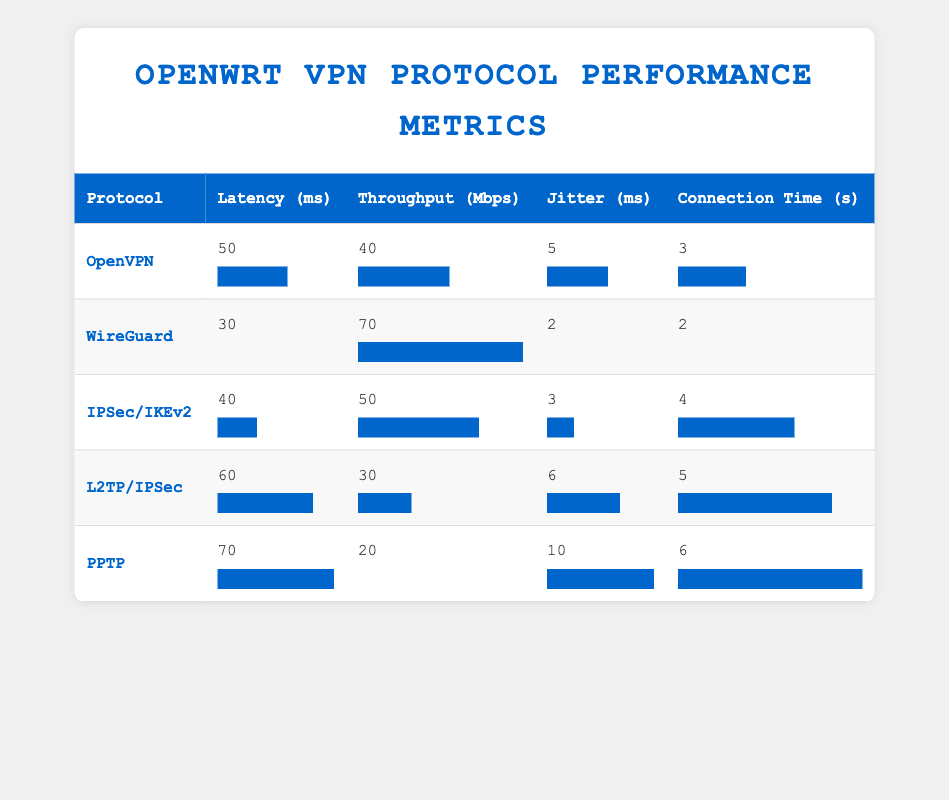What is the latency of OpenVPN? The latency of OpenVPN can be found in the table under the "Latency (ms)" column for the OpenVPN row, which shows 50 milliseconds.
Answer: 50 ms Which VPN protocol has the highest throughput? By reviewing the "Throughput (Mbps)" column, WireGuard is the protocol with the highest throughput at 70 Mbps.
Answer: WireGuard Is there a VPN protocol with a connection time less than 3 seconds? Looking at the "Connection Time (s)" column, both WireGuard with 2 seconds and OpenVPN with 3 seconds are the protocols listed; hence, yes, WireGuard qualifies.
Answer: Yes What is the average jitter of all protocols? The jitter values are 5, 2, 3, 6, and 10 milliseconds. Summing these gives 26 milliseconds, and with 5 protocols, the average is 26/5 = 5.2 milliseconds.
Answer: 5.2 ms Which protocol has the lowest latency? Examining the "Latency (ms)" column, WireGuard has the lowest latency at 30 milliseconds.
Answer: WireGuard By how much does the throughput of IPSec/IKEv2 exceed that of PPTP? The throughput for IPSec/IKEv2 is 50 Mbps while PPTP has 20 Mbps. The difference is 50 - 20 = 30 Mbps.
Answer: 30 Mbps What is the median connection time among the protocols? The connection times are 3, 2, 4, 5, and 6 seconds. Arranging these in order (2, 3, 4, 5, 6), the median is the middle value, which is 4 seconds.
Answer: 4 s Does L2TP/IPSec have a higher latency than OpenVPN? L2TP/IPSec latency is 60 milliseconds while OpenVPN is 50 milliseconds. Since 60 > 50, the statement is true.
Answer: Yes Which protocol has the highest latency and what does that value indicate? Reviewing the "Latency (ms)" column, PPTP has the highest latency of 70 milliseconds. This indicates it may be less suitable for applications sensitive to delays.
Answer: PPTP, 70 ms 